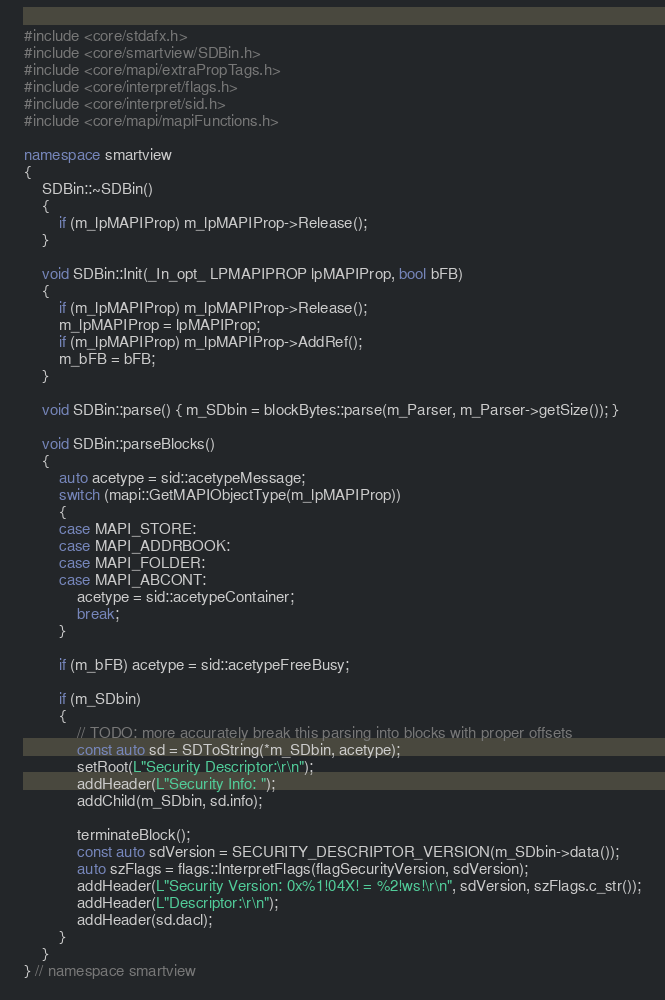<code> <loc_0><loc_0><loc_500><loc_500><_C++_>#include <core/stdafx.h>
#include <core/smartview/SDBin.h>
#include <core/mapi/extraPropTags.h>
#include <core/interpret/flags.h>
#include <core/interpret/sid.h>
#include <core/mapi/mapiFunctions.h>

namespace smartview
{
	SDBin::~SDBin()
	{
		if (m_lpMAPIProp) m_lpMAPIProp->Release();
	}

	void SDBin::Init(_In_opt_ LPMAPIPROP lpMAPIProp, bool bFB)
	{
		if (m_lpMAPIProp) m_lpMAPIProp->Release();
		m_lpMAPIProp = lpMAPIProp;
		if (m_lpMAPIProp) m_lpMAPIProp->AddRef();
		m_bFB = bFB;
	}

	void SDBin::parse() { m_SDbin = blockBytes::parse(m_Parser, m_Parser->getSize()); }

	void SDBin::parseBlocks()
	{
		auto acetype = sid::acetypeMessage;
		switch (mapi::GetMAPIObjectType(m_lpMAPIProp))
		{
		case MAPI_STORE:
		case MAPI_ADDRBOOK:
		case MAPI_FOLDER:
		case MAPI_ABCONT:
			acetype = sid::acetypeContainer;
			break;
		}

		if (m_bFB) acetype = sid::acetypeFreeBusy;

		if (m_SDbin)
		{
			// TODO: more accurately break this parsing into blocks with proper offsets
			const auto sd = SDToString(*m_SDbin, acetype);
			setRoot(L"Security Descriptor:\r\n");
			addHeader(L"Security Info: ");
			addChild(m_SDbin, sd.info);

			terminateBlock();
			const auto sdVersion = SECURITY_DESCRIPTOR_VERSION(m_SDbin->data());
			auto szFlags = flags::InterpretFlags(flagSecurityVersion, sdVersion);
			addHeader(L"Security Version: 0x%1!04X! = %2!ws!\r\n", sdVersion, szFlags.c_str());
			addHeader(L"Descriptor:\r\n");
			addHeader(sd.dacl);
		}
	}
} // namespace smartview</code> 